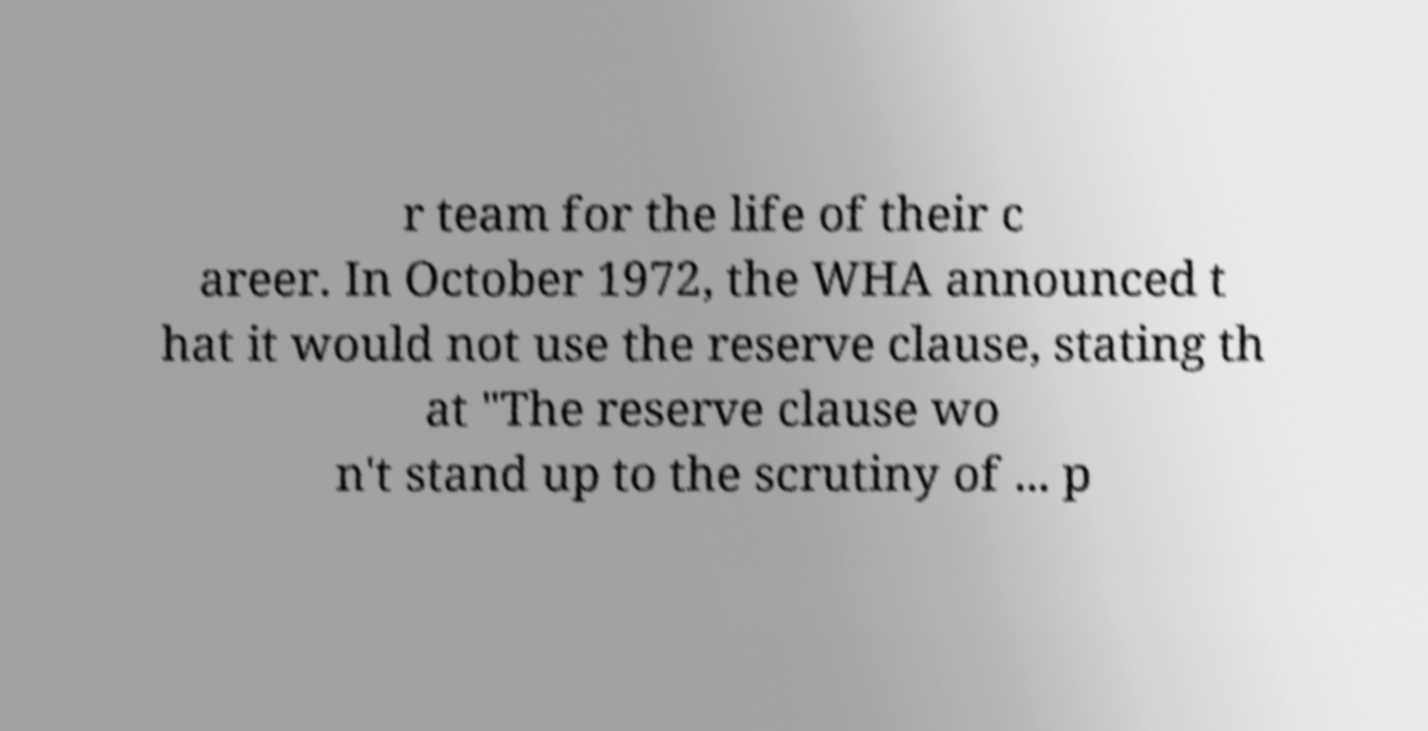Can you read and provide the text displayed in the image?This photo seems to have some interesting text. Can you extract and type it out for me? r team for the life of their c areer. In October 1972, the WHA announced t hat it would not use the reserve clause, stating th at "The reserve clause wo n't stand up to the scrutiny of ... p 